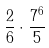<formula> <loc_0><loc_0><loc_500><loc_500>\frac { 2 } { 6 } \cdot \frac { 7 ^ { 6 } } { 5 }</formula> 